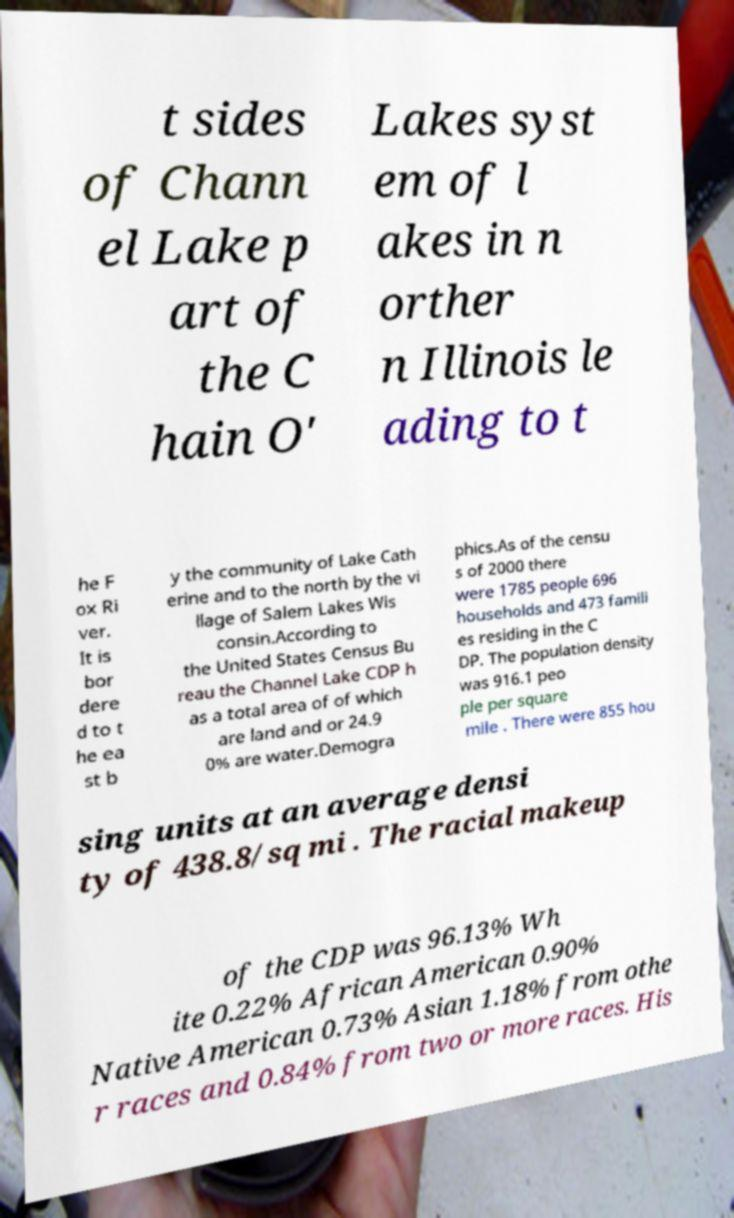Could you extract and type out the text from this image? t sides of Chann el Lake p art of the C hain O' Lakes syst em of l akes in n orther n Illinois le ading to t he F ox Ri ver. It is bor dere d to t he ea st b y the community of Lake Cath erine and to the north by the vi llage of Salem Lakes Wis consin.According to the United States Census Bu reau the Channel Lake CDP h as a total area of of which are land and or 24.9 0% are water.Demogra phics.As of the censu s of 2000 there were 1785 people 696 households and 473 famili es residing in the C DP. The population density was 916.1 peo ple per square mile . There were 855 hou sing units at an average densi ty of 438.8/sq mi . The racial makeup of the CDP was 96.13% Wh ite 0.22% African American 0.90% Native American 0.73% Asian 1.18% from othe r races and 0.84% from two or more races. His 